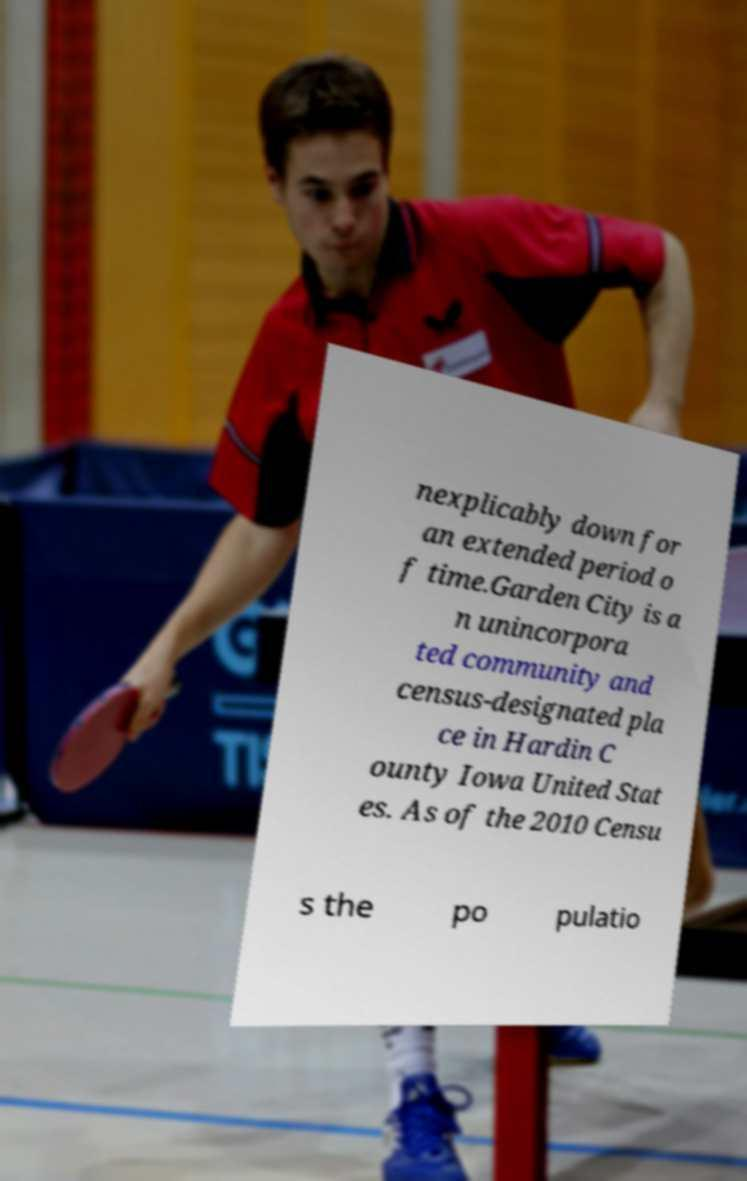There's text embedded in this image that I need extracted. Can you transcribe it verbatim? nexplicably down for an extended period o f time.Garden City is a n unincorpora ted community and census-designated pla ce in Hardin C ounty Iowa United Stat es. As of the 2010 Censu s the po pulatio 